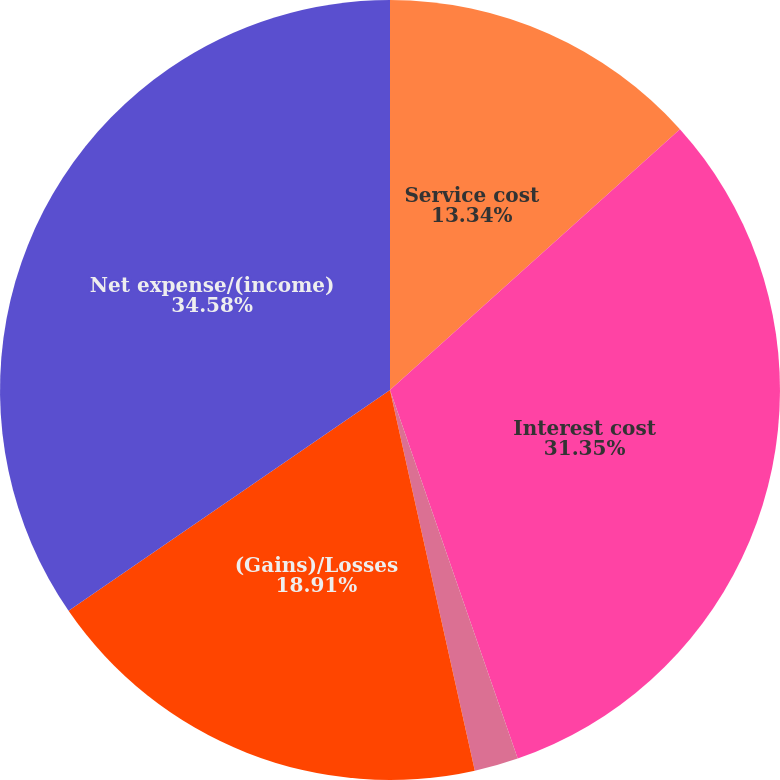<chart> <loc_0><loc_0><loc_500><loc_500><pie_chart><fcel>Service cost<fcel>Interest cost<fcel>Prior service costs/(credits)<fcel>(Gains)/Losses<fcel>Net expense/(income)<nl><fcel>13.34%<fcel>31.35%<fcel>1.82%<fcel>18.91%<fcel>34.58%<nl></chart> 